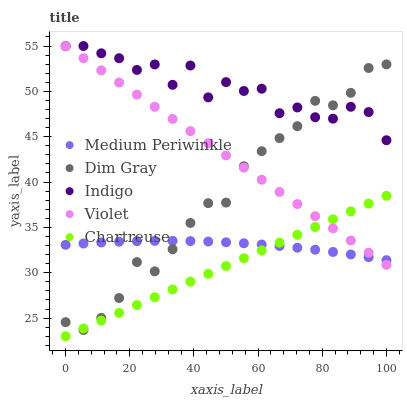Does Chartreuse have the minimum area under the curve?
Answer yes or no. Yes. Does Indigo have the maximum area under the curve?
Answer yes or no. Yes. Does Dim Gray have the minimum area under the curve?
Answer yes or no. No. Does Dim Gray have the maximum area under the curve?
Answer yes or no. No. Is Violet the smoothest?
Answer yes or no. Yes. Is Indigo the roughest?
Answer yes or no. Yes. Is Chartreuse the smoothest?
Answer yes or no. No. Is Chartreuse the roughest?
Answer yes or no. No. Does Chartreuse have the lowest value?
Answer yes or no. Yes. Does Dim Gray have the lowest value?
Answer yes or no. No. Does Violet have the highest value?
Answer yes or no. Yes. Does Chartreuse have the highest value?
Answer yes or no. No. Is Chartreuse less than Indigo?
Answer yes or no. Yes. Is Indigo greater than Chartreuse?
Answer yes or no. Yes. Does Violet intersect Medium Periwinkle?
Answer yes or no. Yes. Is Violet less than Medium Periwinkle?
Answer yes or no. No. Is Violet greater than Medium Periwinkle?
Answer yes or no. No. Does Chartreuse intersect Indigo?
Answer yes or no. No. 